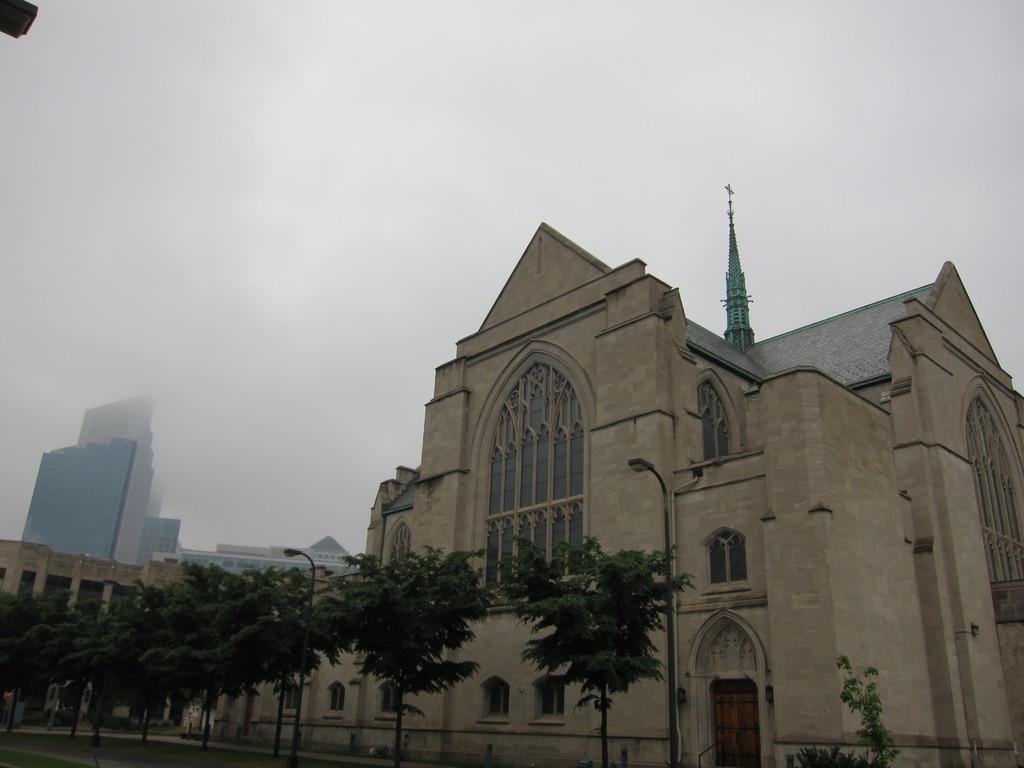Describe this image in one or two sentences. In this image there is a building, and at the bottom there are some poles, street lights, trees and grass. In the background also there are buildings, at the top the sky is cloudy. 